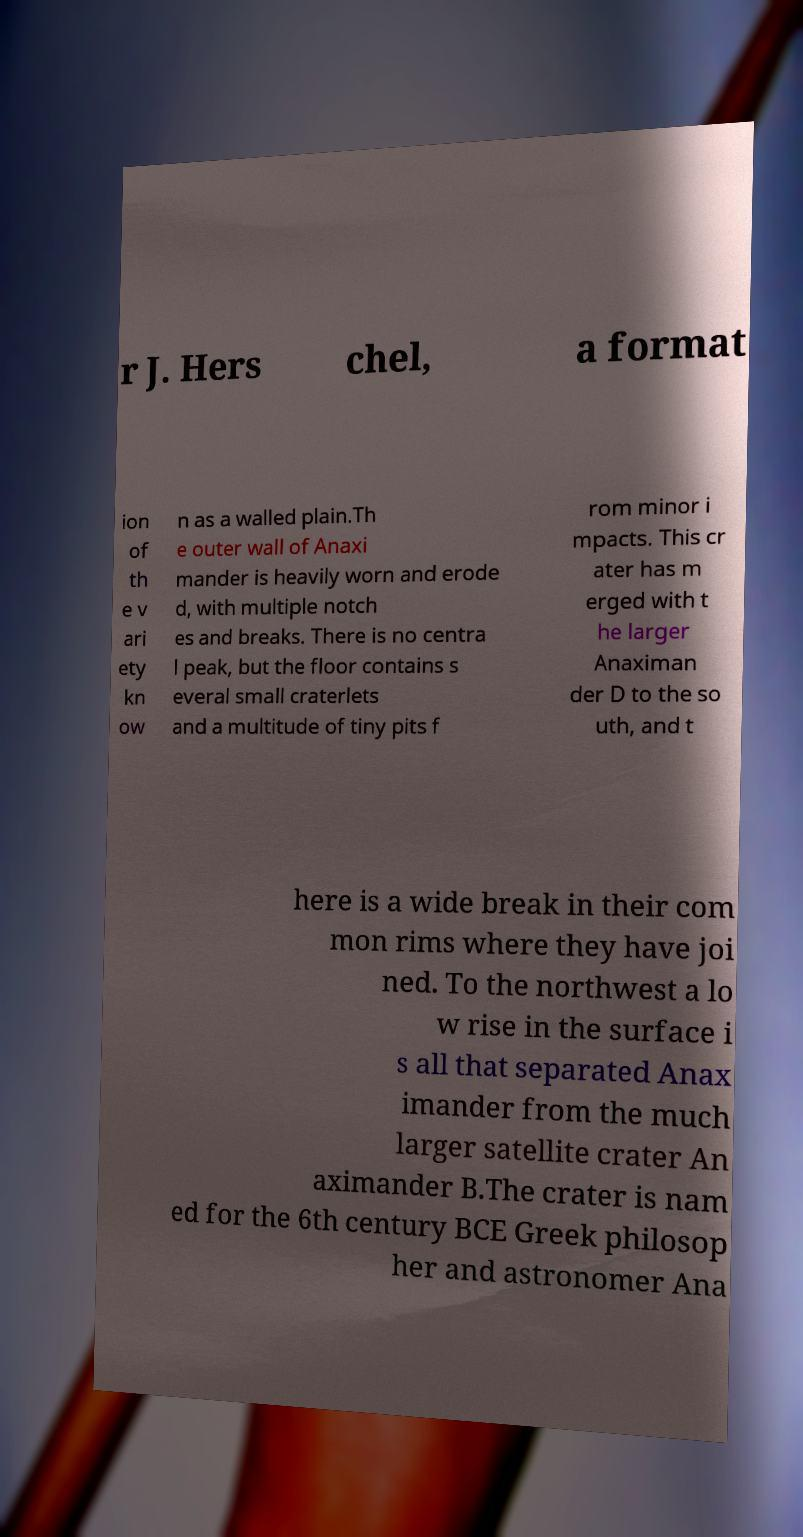For documentation purposes, I need the text within this image transcribed. Could you provide that? r J. Hers chel, a format ion of th e v ari ety kn ow n as a walled plain.Th e outer wall of Anaxi mander is heavily worn and erode d, with multiple notch es and breaks. There is no centra l peak, but the floor contains s everal small craterlets and a multitude of tiny pits f rom minor i mpacts. This cr ater has m erged with t he larger Anaximan der D to the so uth, and t here is a wide break in their com mon rims where they have joi ned. To the northwest a lo w rise in the surface i s all that separated Anax imander from the much larger satellite crater An aximander B.The crater is nam ed for the 6th century BCE Greek philosop her and astronomer Ana 